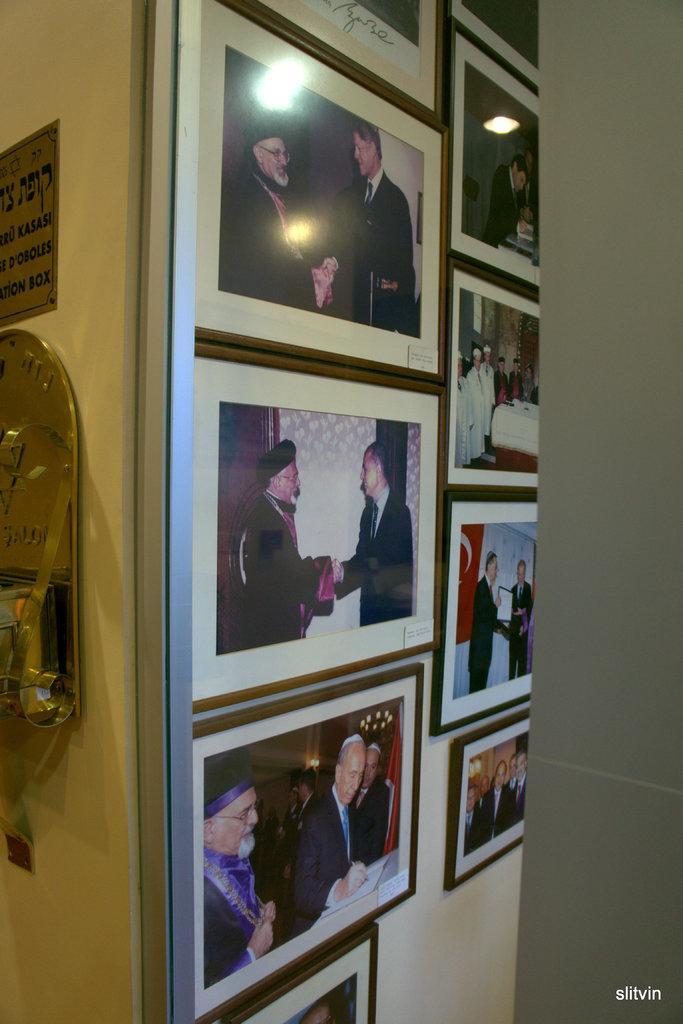Can you describe this image briefly? In this image we can see photo frames attached to the wall and a name board. 